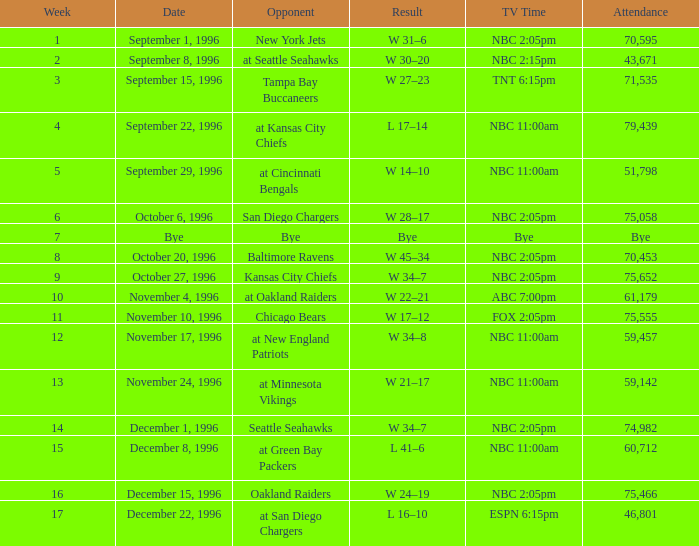WHAT IS THE RESULT WHEN THE OPPONENT WAS CHICAGO BEARS? W 17–12. Would you be able to parse every entry in this table? {'header': ['Week', 'Date', 'Opponent', 'Result', 'TV Time', 'Attendance'], 'rows': [['1', 'September 1, 1996', 'New York Jets', 'W 31–6', 'NBC 2:05pm', '70,595'], ['2', 'September 8, 1996', 'at Seattle Seahawks', 'W 30–20', 'NBC 2:15pm', '43,671'], ['3', 'September 15, 1996', 'Tampa Bay Buccaneers', 'W 27–23', 'TNT 6:15pm', '71,535'], ['4', 'September 22, 1996', 'at Kansas City Chiefs', 'L 17–14', 'NBC 11:00am', '79,439'], ['5', 'September 29, 1996', 'at Cincinnati Bengals', 'W 14–10', 'NBC 11:00am', '51,798'], ['6', 'October 6, 1996', 'San Diego Chargers', 'W 28–17', 'NBC 2:05pm', '75,058'], ['7', 'Bye', 'Bye', 'Bye', 'Bye', 'Bye'], ['8', 'October 20, 1996', 'Baltimore Ravens', 'W 45–34', 'NBC 2:05pm', '70,453'], ['9', 'October 27, 1996', 'Kansas City Chiefs', 'W 34–7', 'NBC 2:05pm', '75,652'], ['10', 'November 4, 1996', 'at Oakland Raiders', 'W 22–21', 'ABC 7:00pm', '61,179'], ['11', 'November 10, 1996', 'Chicago Bears', 'W 17–12', 'FOX 2:05pm', '75,555'], ['12', 'November 17, 1996', 'at New England Patriots', 'W 34–8', 'NBC 11:00am', '59,457'], ['13', 'November 24, 1996', 'at Minnesota Vikings', 'W 21–17', 'NBC 11:00am', '59,142'], ['14', 'December 1, 1996', 'Seattle Seahawks', 'W 34–7', 'NBC 2:05pm', '74,982'], ['15', 'December 8, 1996', 'at Green Bay Packers', 'L 41–6', 'NBC 11:00am', '60,712'], ['16', 'December 15, 1996', 'Oakland Raiders', 'W 24–19', 'NBC 2:05pm', '75,466'], ['17', 'December 22, 1996', 'at San Diego Chargers', 'L 16–10', 'ESPN 6:15pm', '46,801']]} 